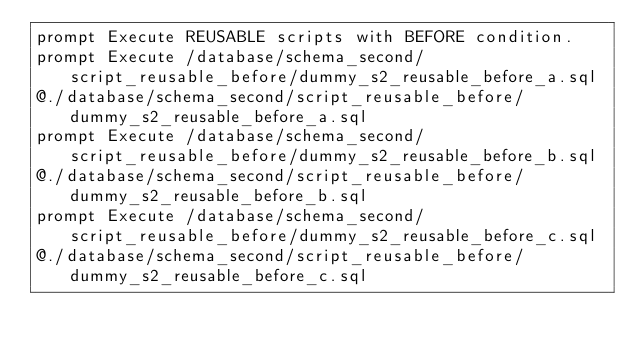<code> <loc_0><loc_0><loc_500><loc_500><_SQL_>prompt Execute REUSABLE scripts with BEFORE condition.
prompt Execute /database/schema_second/script_reusable_before/dummy_s2_reusable_before_a.sql
@./database/schema_second/script_reusable_before/dummy_s2_reusable_before_a.sql
prompt Execute /database/schema_second/script_reusable_before/dummy_s2_reusable_before_b.sql
@./database/schema_second/script_reusable_before/dummy_s2_reusable_before_b.sql
prompt Execute /database/schema_second/script_reusable_before/dummy_s2_reusable_before_c.sql
@./database/schema_second/script_reusable_before/dummy_s2_reusable_before_c.sql
</code> 